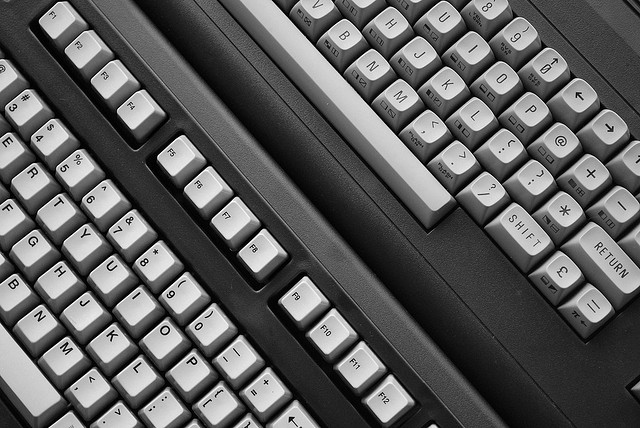Could you tell me more about the layout of the keys? Absolutely. The arrangement of keys in the image appears to be a QWERTY layout, which is the most widely used keyboard layout for English-language typewriters and computers. It was designed to reduce the likelihood of typebar clashes and jams by placing commonly used letters further apart. 